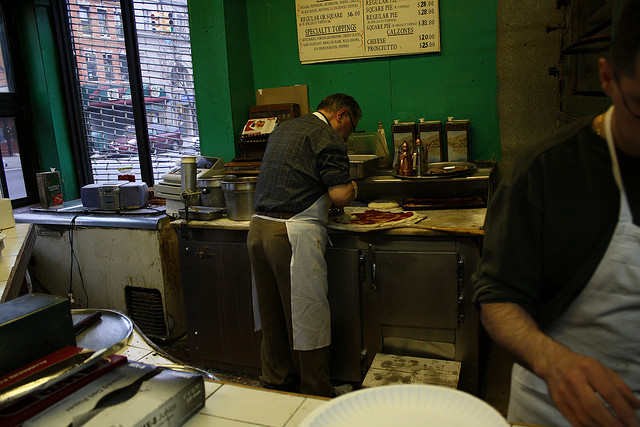Please transcribe the text in this image. 25 